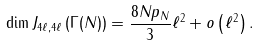<formula> <loc_0><loc_0><loc_500><loc_500>\dim J _ { 4 \ell , 4 \ell } \left ( \Gamma ( N ) \right ) = \frac { 8 N p _ { N } } { 3 } \ell ^ { 2 } + o \left ( \ell ^ { 2 } \right ) .</formula> 